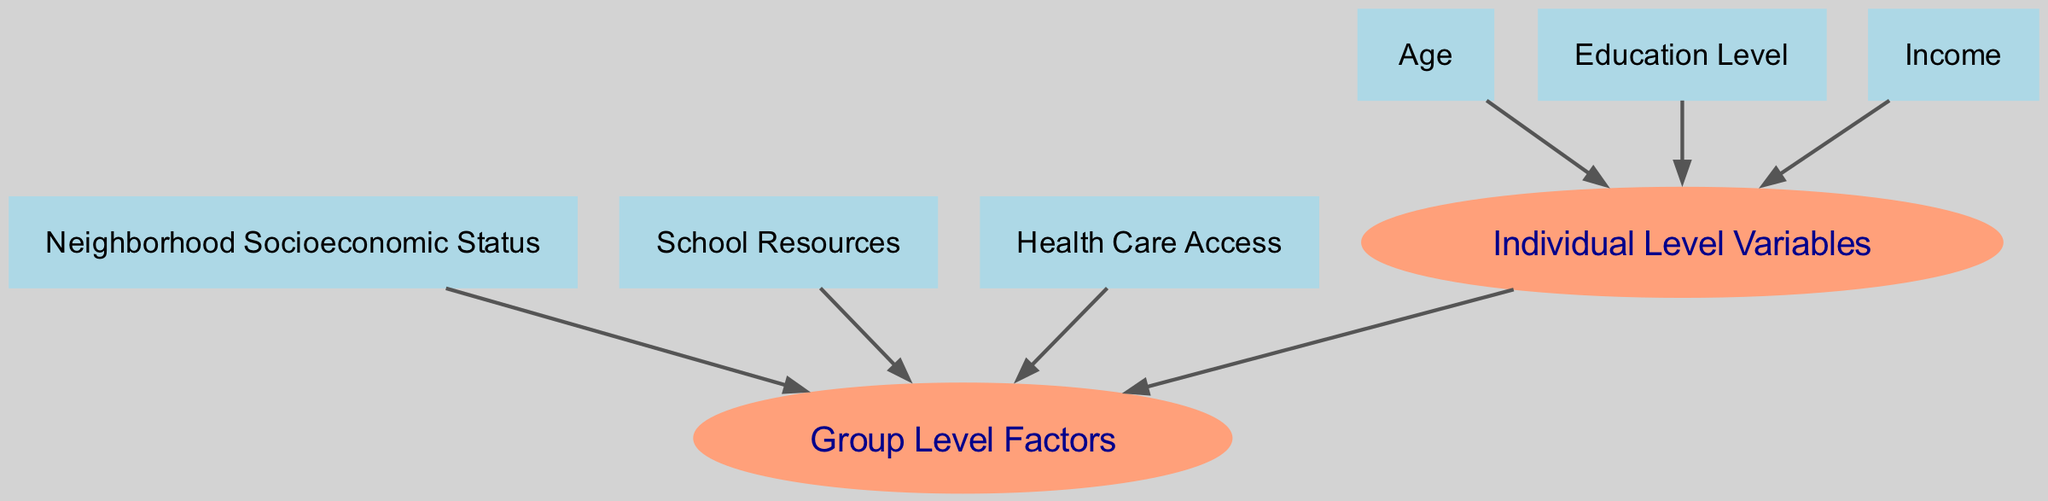What are the individual-level variables in the diagram? The nodes that represent individual-level variables are directly connected to the "Individual Level Variables" node. The corresponding nodes are "Age," "Education Level," and "Income."
Answer: Age, Education Level, Income How many group-level factors are shown in the diagram? The "Group Level Factors" node has three edges coming from the corresponding nodes: "Neighborhood Socioeconomic Status," "School Resources," and "Health Care Access." Therefore, there are three group-level factors.
Answer: 3 Which individual-level variable has a direct connection to the group-level factors? The "Individual Level Variables" node is connected to the "Group Level Factors" node, indicating that individual-level variables have a relationship with group-level factors.
Answer: Individual Level Variables What is the relationship between "Age" and "Group Level Factors"? "Age" connects to "Individual Level Variables," which then has a direct connection to "Group Level Factors." Therefore, there is no direct edge between "Age" and "Group Level Factors," but there is an indirect relationship through "Individual Level Variables."
Answer: Indirect relationship Which individual-level variable connects to the "Individual Level Variables" node? "Age," "Education Level," and "Income" all connect to the "Individual Level Variables" node with individual edges.
Answer: Age, Education Level, Income How many edges are there from group-level factors to individual-level variables? There is one edge going from "Individual Level Variables" to "Group Level Factors" indicating that individual-level variables can influence or be influenced by group-level factors. No edges go from group-level factors to individual-level variables.
Answer: 1 What type of graph is represented in the diagram? The diagram represents a directed graph as it shows directional relationships through arrows indicating influence or connection.
Answer: Directed graph Which node serves as a hub connecting individual and group-level variables? The "Individual Level Variables" acts as a hub because it connects individual-level variables with the group-level factors through directed edges.
Answer: Individual Level Variables What is the main purpose of the diagram? The main purpose of the diagram is to illustrate the structure of a multilevel model by showing the relationships between individual-level and group-level factors.
Answer: Illustrate multilevel model structure 